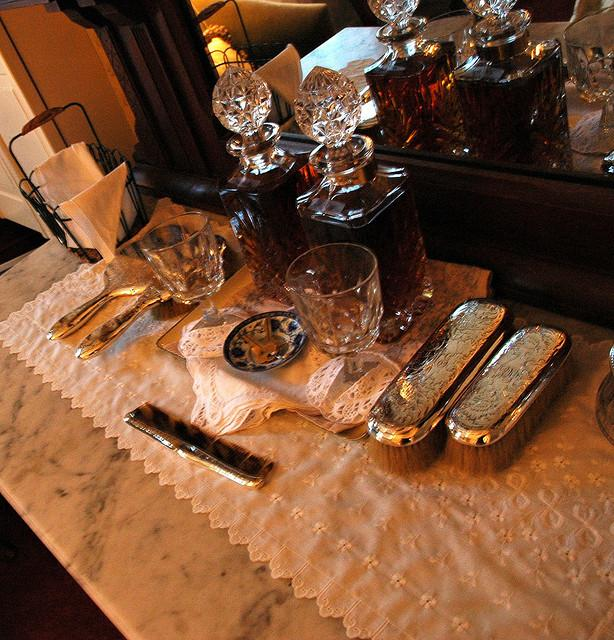What is most likely in the glass with the round top? Please explain your reasoning. alcohol. This is a decanter and they are made to hold alcohol most often. 